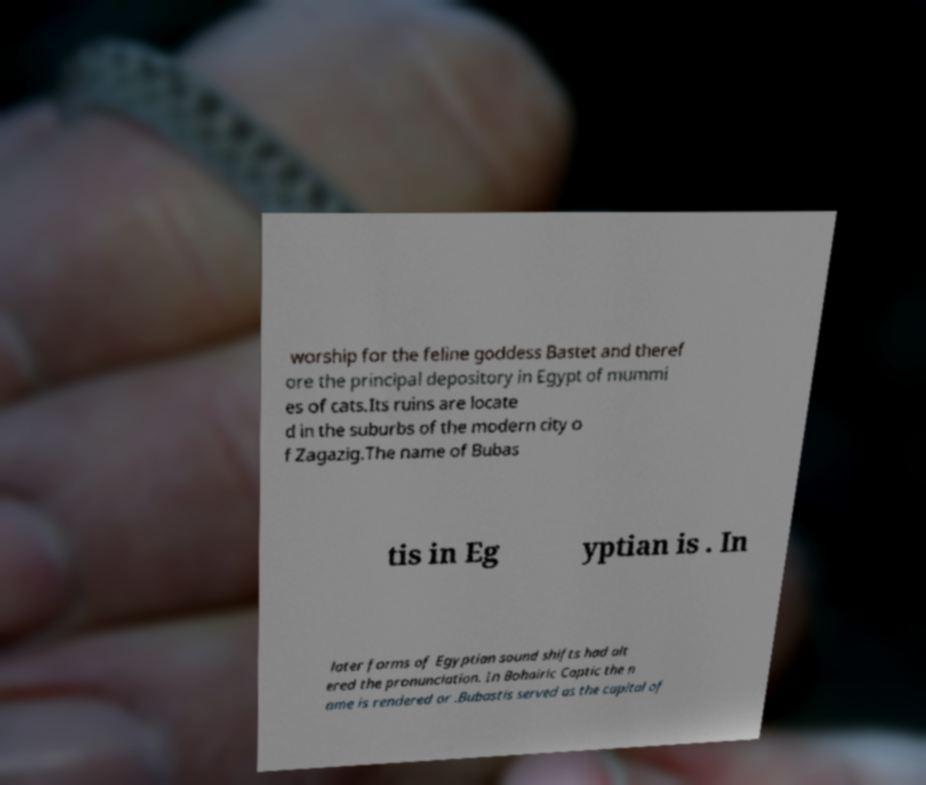Can you read and provide the text displayed in the image?This photo seems to have some interesting text. Can you extract and type it out for me? worship for the feline goddess Bastet and theref ore the principal depository in Egypt of mummi es of cats.Its ruins are locate d in the suburbs of the modern city o f Zagazig.The name of Bubas tis in Eg yptian is . In later forms of Egyptian sound shifts had alt ered the pronunciation. In Bohairic Coptic the n ame is rendered or .Bubastis served as the capital of 